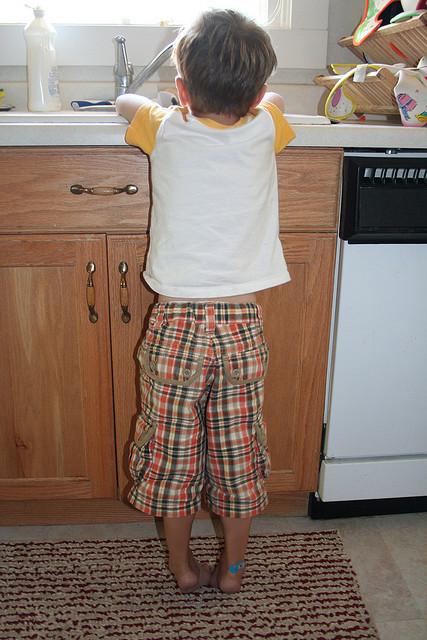How many boys are there?
Be succinct. 1. What is the wooden rack used for?
Give a very brief answer. Drying dishes. What appliance is the boy standing next to?
Answer briefly. Dishwasher. 